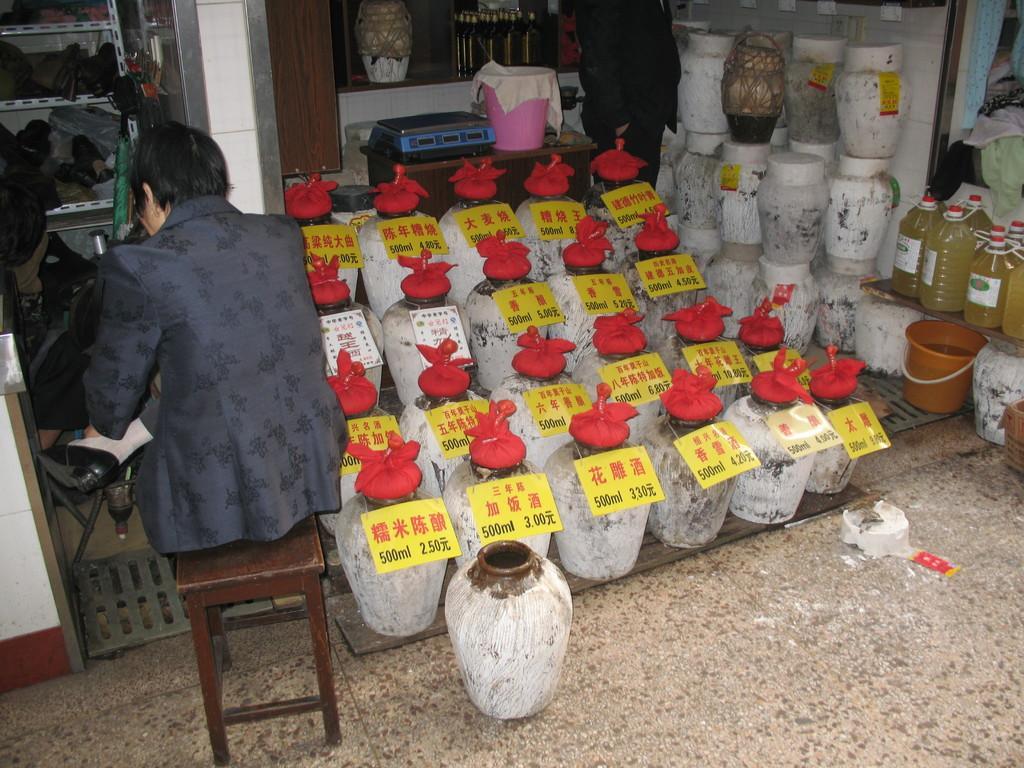Please provide a concise description of this image. In this image we can see a person sitting on a stool. Here we can see pots, price tags, bucket, cloth, bin, bottles, rack, and objects. Here we can see a person standing on the floor. There is a wall. 